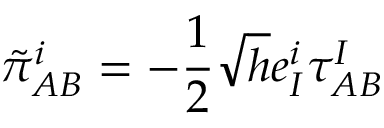<formula> <loc_0><loc_0><loc_500><loc_500>\tilde { \pi } _ { A B } ^ { i } = - \frac { 1 } { 2 } \sqrt { h } e _ { I } ^ { i } \tau _ { A B } ^ { I }</formula> 